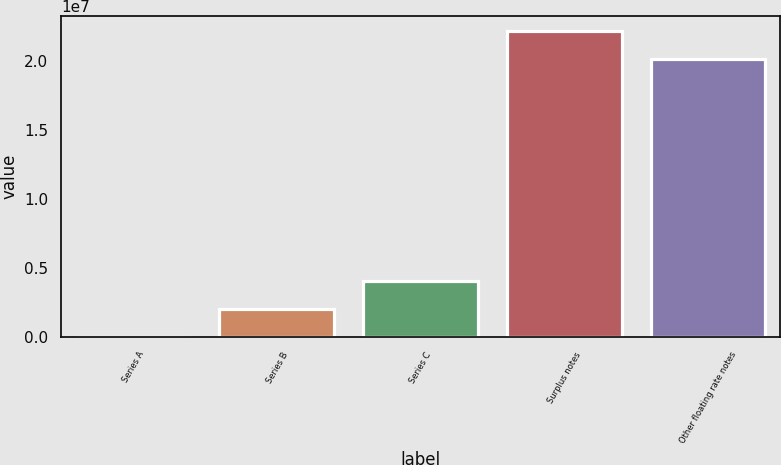<chart> <loc_0><loc_0><loc_500><loc_500><bar_chart><fcel>Series A<fcel>Series B<fcel>Series C<fcel>Surplus notes<fcel>Other floating rate notes<nl><fcel>20171<fcel>2.03436e+06<fcel>4.04855e+06<fcel>2.21262e+07<fcel>2.0112e+07<nl></chart> 